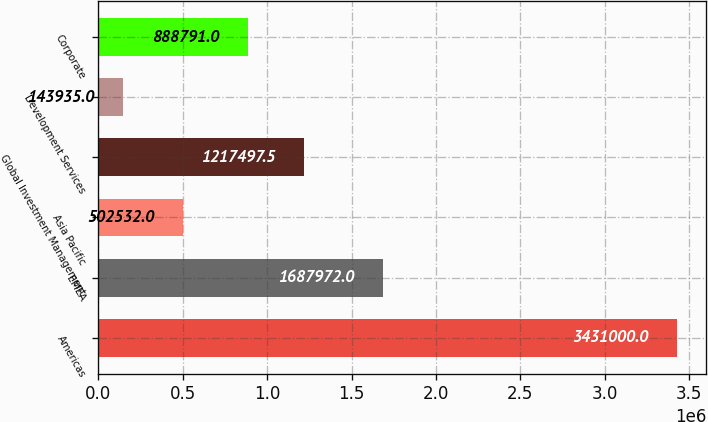<chart> <loc_0><loc_0><loc_500><loc_500><bar_chart><fcel>Americas<fcel>EMEA<fcel>Asia Pacific<fcel>Global Investment Management<fcel>Development Services<fcel>Corporate<nl><fcel>3.431e+06<fcel>1.68797e+06<fcel>502532<fcel>1.2175e+06<fcel>143935<fcel>888791<nl></chart> 